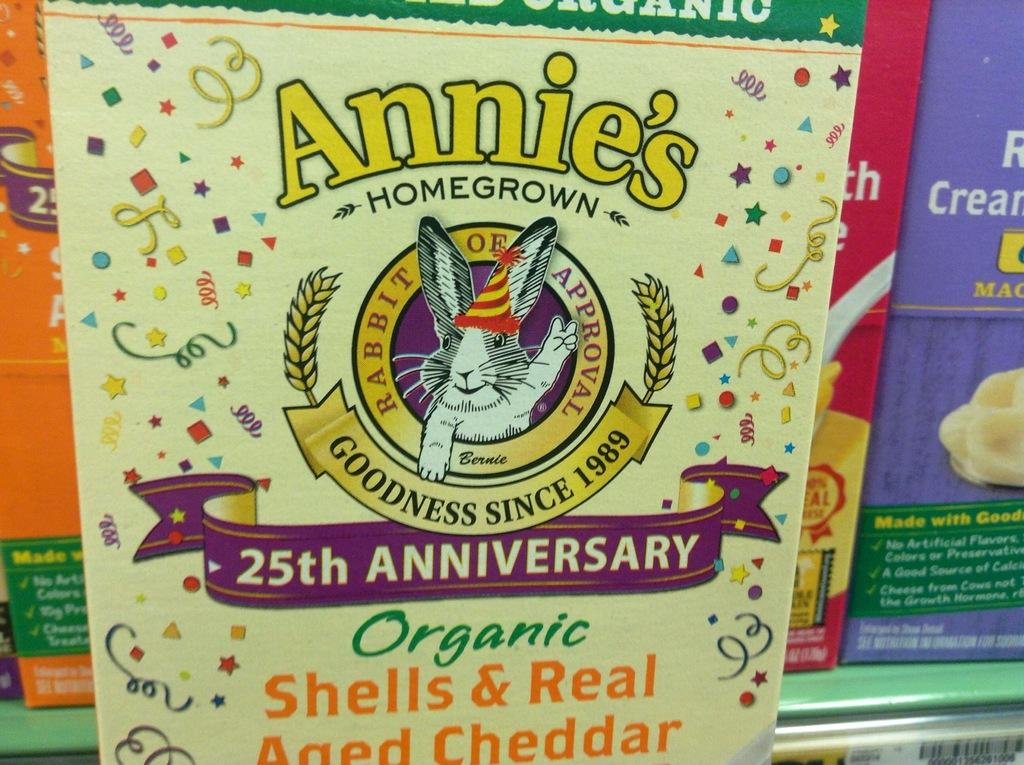What is the main object in the image? There is a box in the image. What is featured on the box? There is an animal depicted on the box. What information is provided on the box? Something is written on the box. What can be seen in the background of the image? There are colorful boxes in the background of the image. How are the colorful boxes arranged in the image? The colorful boxes are in a rack. What type of silk is used to make the drum in the image? There is no drum or silk present in the image; it features a box with an animal depicted on it and colorful boxes in a rack in the background. 